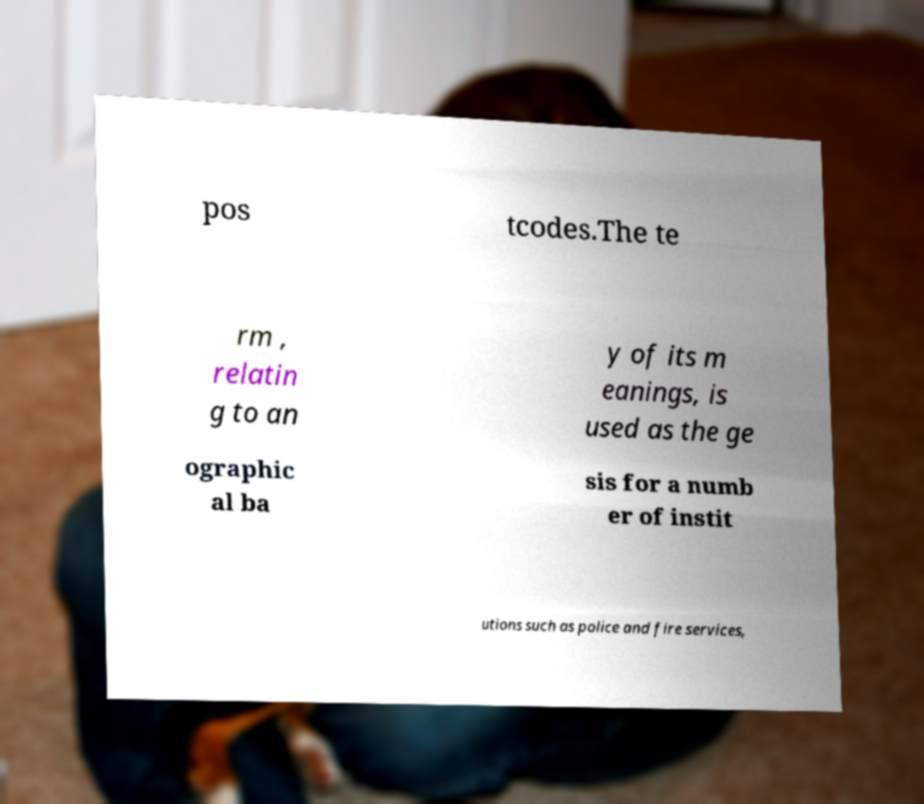Can you accurately transcribe the text from the provided image for me? pos tcodes.The te rm , relatin g to an y of its m eanings, is used as the ge ographic al ba sis for a numb er of instit utions such as police and fire services, 